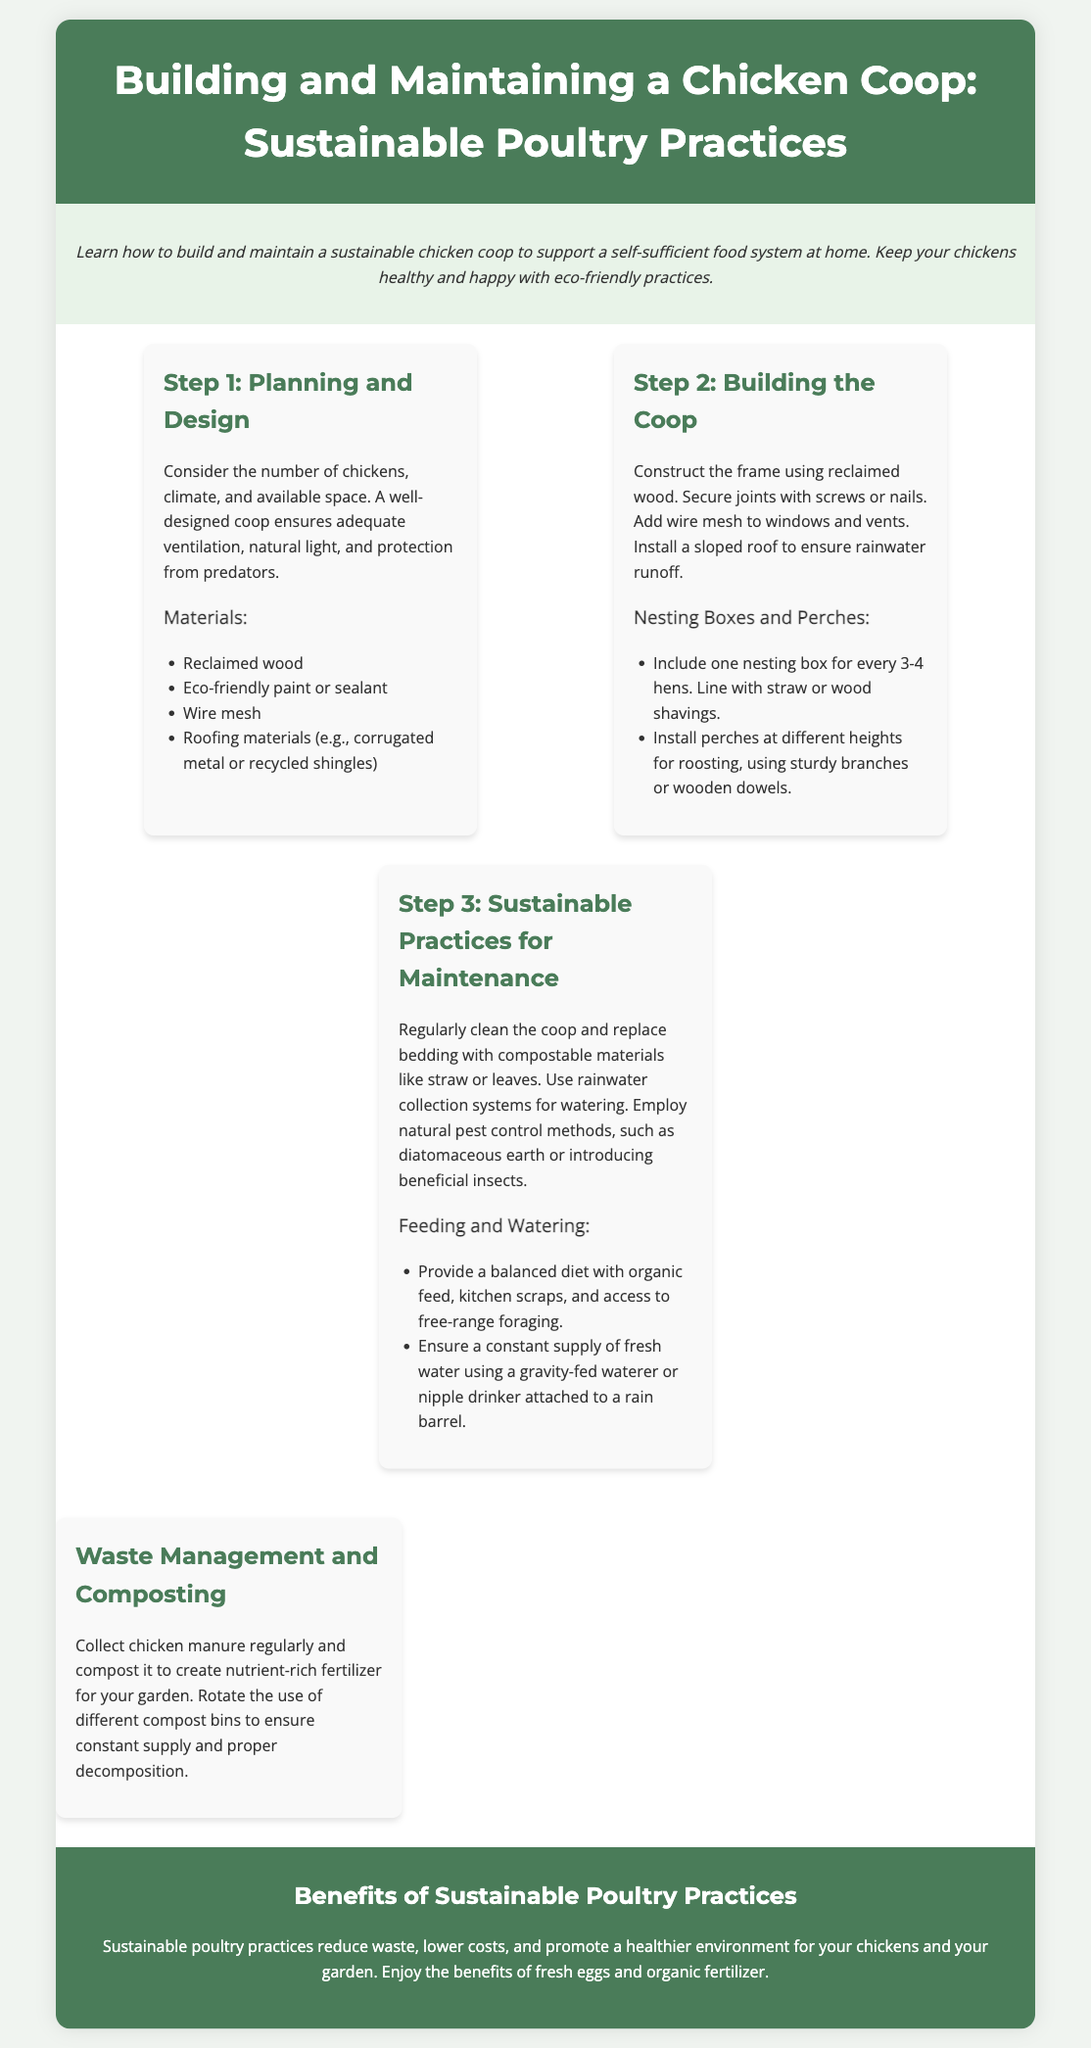What is the first step in building a chicken coop? The document states that the first step is "Planning and Design."
Answer: Planning and Design How many nesting boxes should be included for 3-4 hens? According to the document, one nesting box is recommended for every 3-4 hens.
Answer: One What type of wood is suggested for constructing the coop? The document specifies "reclaimed wood" for constructing the coop.
Answer: Reclaimed wood What should be used to line the nesting boxes? The document notes that nesting boxes should be lined with "straw or wood shavings."
Answer: Straw or wood shavings What system can be employed for watering the chickens sustainably? The document recommends using a "gravity-fed waterer or nipple drinker attached to a rain barrel."
Answer: Gravity-fed waterer or nipple drinker How often should the coop be cleaned? The document emphasizes the importance of "regularly" cleaning the coop as part of maintenance.
Answer: Regularly What is a benefit of sustainable poultry practices mentioned in the document? The document states that sustainable poultry practices "reduce waste."
Answer: Reduce waste What materials are listed for coop construction? The document lists "reclaimed wood, eco-friendly paint or sealant, wire mesh, roofing materials" as materials for coop construction.
Answer: Reclaimed wood, eco-friendly paint or sealant, wire mesh, roofing materials How should chicken manure be handled? The document advises to "collect chicken manure regularly and compost it."
Answer: Collect and compost 